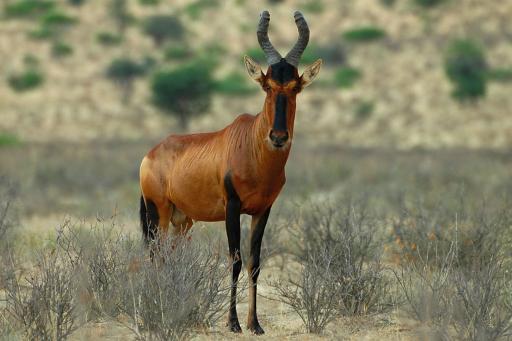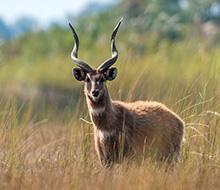The first image is the image on the left, the second image is the image on the right. For the images shown, is this caption "The left and right image contains the same number of standing elk." true? Answer yes or no. Yes. The first image is the image on the left, the second image is the image on the right. Examine the images to the left and right. Is the description "Each image contains one horned animal, and the animals on the left and right have their heads turned in the same direction." accurate? Answer yes or no. Yes. 